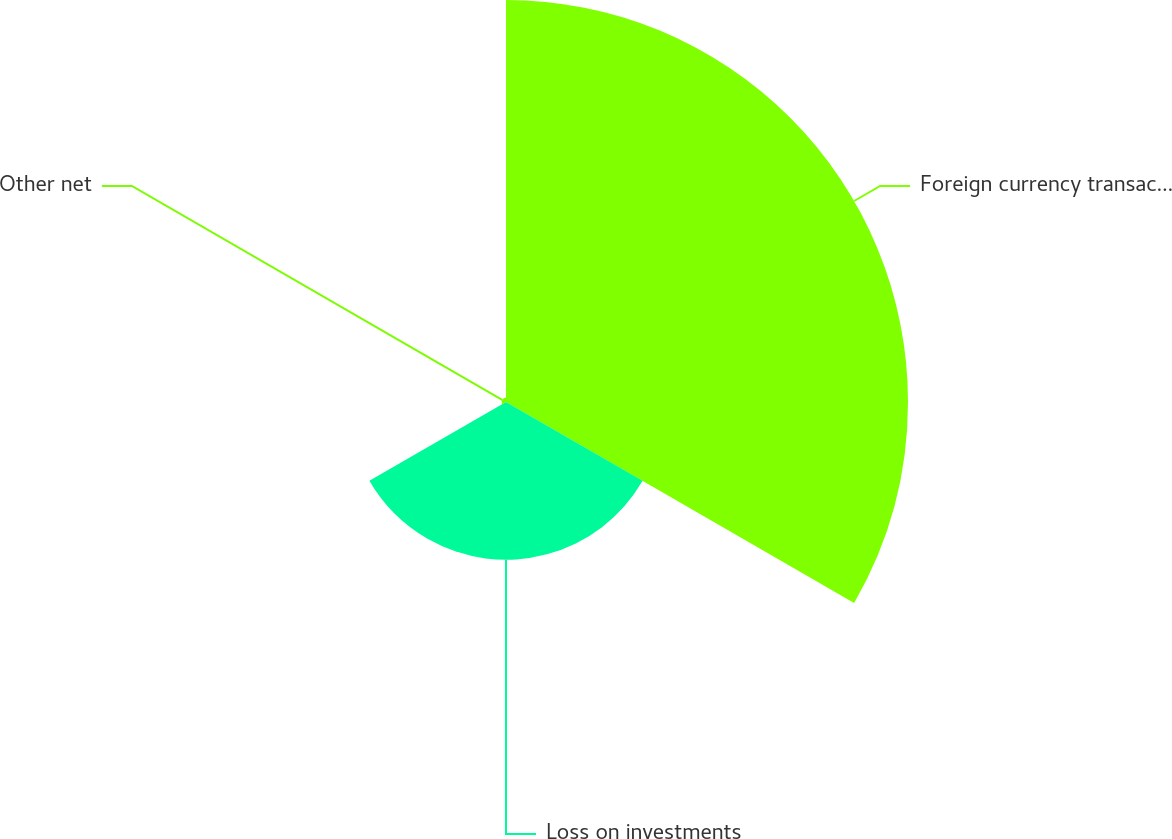Convert chart to OTSL. <chart><loc_0><loc_0><loc_500><loc_500><pie_chart><fcel>Foreign currency transaction<fcel>Loss on investments<fcel>Other net<nl><fcel>71.26%<fcel>27.96%<fcel>0.78%<nl></chart> 